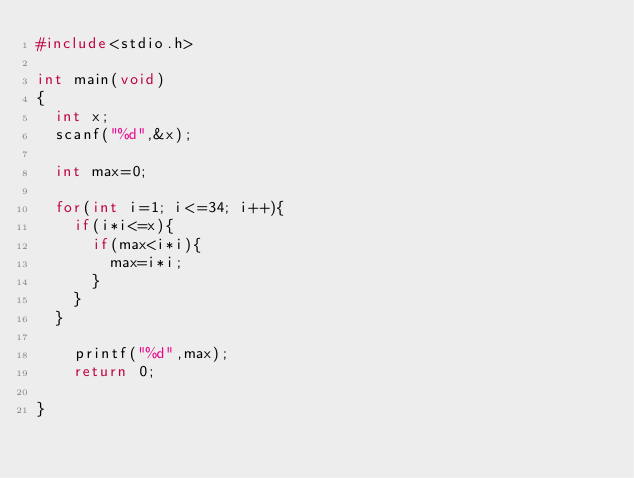Convert code to text. <code><loc_0><loc_0><loc_500><loc_500><_C_>#include<stdio.h>

int main(void)
{
  int x;
  scanf("%d",&x);

  int max=0;

  for(int i=1; i<=34; i++){
    if(i*i<=x){
      if(max<i*i){
        max=i*i;
      }
    }
  }

    printf("%d",max);
    return 0;

}
</code> 